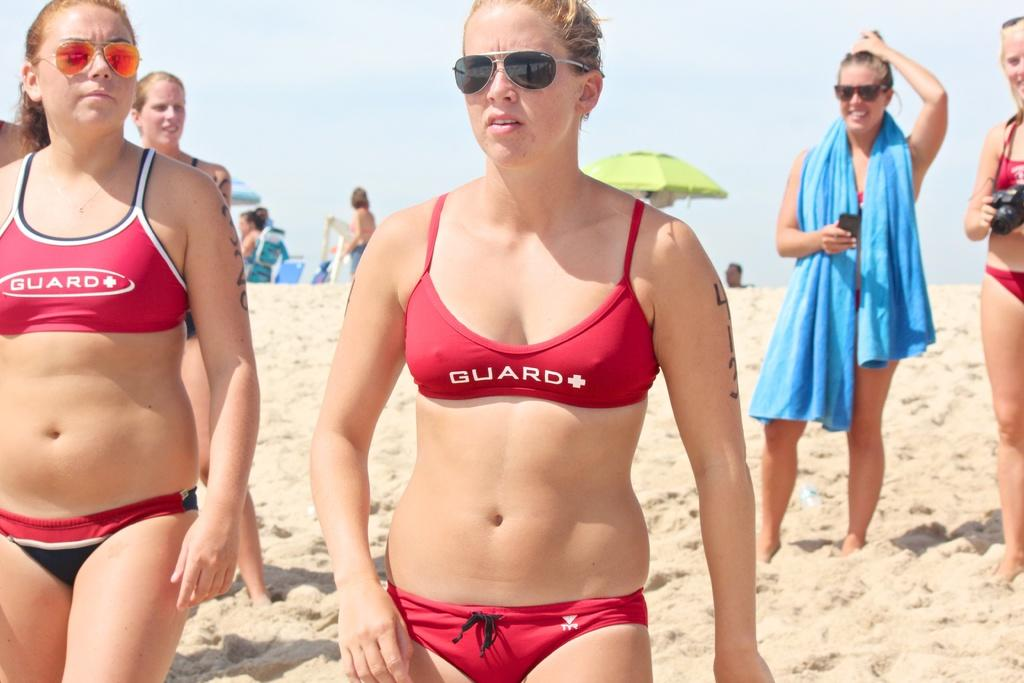<image>
Give a short and clear explanation of the subsequent image. Two women at a beach wearing red GUARD bikinis. 